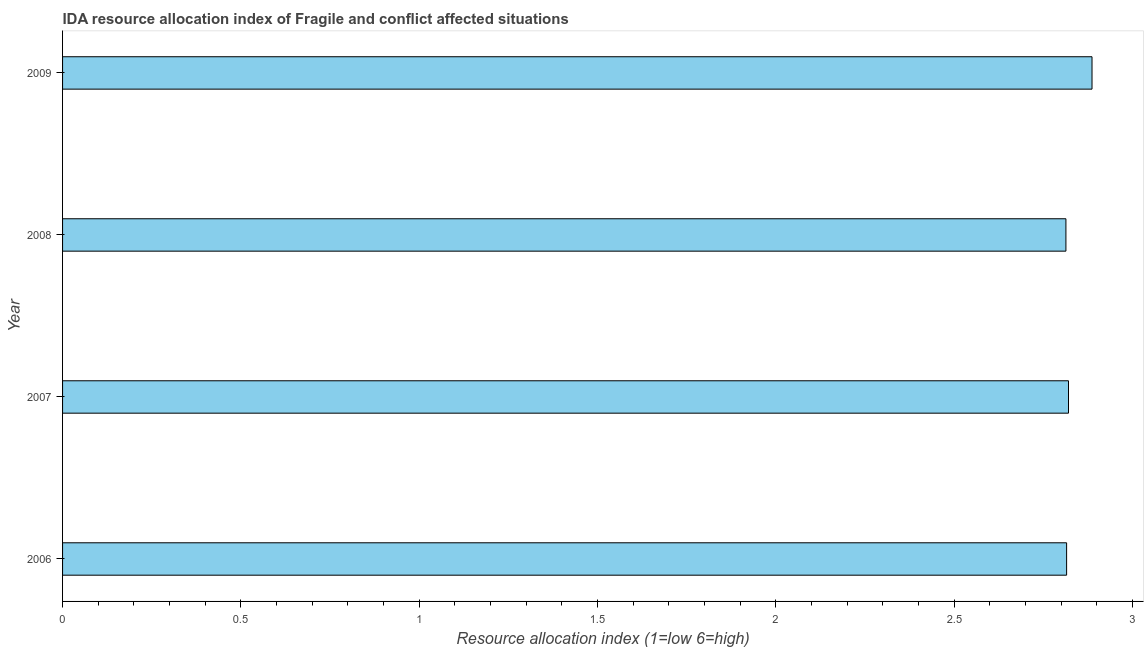Does the graph contain any zero values?
Keep it short and to the point. No. What is the title of the graph?
Provide a short and direct response. IDA resource allocation index of Fragile and conflict affected situations. What is the label or title of the X-axis?
Give a very brief answer. Resource allocation index (1=low 6=high). What is the ida resource allocation index in 2006?
Offer a terse response. 2.82. Across all years, what is the maximum ida resource allocation index?
Give a very brief answer. 2.89. Across all years, what is the minimum ida resource allocation index?
Offer a terse response. 2.81. What is the sum of the ida resource allocation index?
Make the answer very short. 11.34. What is the difference between the ida resource allocation index in 2006 and 2009?
Your response must be concise. -0.07. What is the average ida resource allocation index per year?
Make the answer very short. 2.83. What is the median ida resource allocation index?
Offer a very short reply. 2.82. In how many years, is the ida resource allocation index greater than 1.6 ?
Ensure brevity in your answer.  4. Is the ida resource allocation index in 2006 less than that in 2007?
Your answer should be very brief. Yes. What is the difference between the highest and the second highest ida resource allocation index?
Keep it short and to the point. 0.07. What is the difference between the highest and the lowest ida resource allocation index?
Provide a short and direct response. 0.07. In how many years, is the ida resource allocation index greater than the average ida resource allocation index taken over all years?
Your answer should be compact. 1. How many bars are there?
Your answer should be compact. 4. What is the difference between two consecutive major ticks on the X-axis?
Make the answer very short. 0.5. What is the Resource allocation index (1=low 6=high) of 2006?
Offer a very short reply. 2.82. What is the Resource allocation index (1=low 6=high) in 2007?
Offer a very short reply. 2.82. What is the Resource allocation index (1=low 6=high) in 2008?
Your answer should be compact. 2.81. What is the Resource allocation index (1=low 6=high) in 2009?
Your answer should be compact. 2.89. What is the difference between the Resource allocation index (1=low 6=high) in 2006 and 2007?
Offer a terse response. -0.01. What is the difference between the Resource allocation index (1=low 6=high) in 2006 and 2008?
Give a very brief answer. 0. What is the difference between the Resource allocation index (1=low 6=high) in 2006 and 2009?
Your answer should be compact. -0.07. What is the difference between the Resource allocation index (1=low 6=high) in 2007 and 2008?
Your response must be concise. 0.01. What is the difference between the Resource allocation index (1=low 6=high) in 2007 and 2009?
Your response must be concise. -0.07. What is the difference between the Resource allocation index (1=low 6=high) in 2008 and 2009?
Keep it short and to the point. -0.07. What is the ratio of the Resource allocation index (1=low 6=high) in 2006 to that in 2007?
Your response must be concise. 1. What is the ratio of the Resource allocation index (1=low 6=high) in 2006 to that in 2008?
Offer a very short reply. 1. What is the ratio of the Resource allocation index (1=low 6=high) in 2007 to that in 2009?
Your answer should be compact. 0.98. 